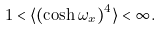<formula> <loc_0><loc_0><loc_500><loc_500>1 < \langle ( \cosh \omega _ { x } ) ^ { 4 } \rangle < \infty .</formula> 